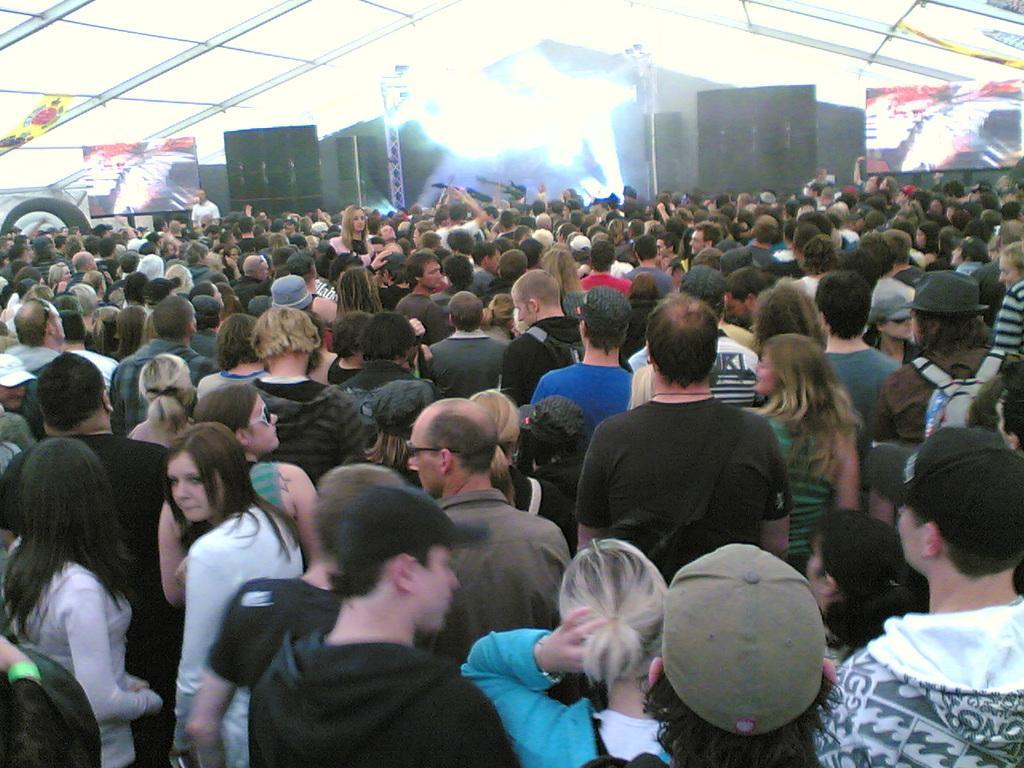Describe this image in one or two sentences. In this picture, we see many people are standing. In the background, we see men are holding the musical instruments in their hands. Behind them, we see speaker boxes and poles. On either side of the picture, we see screens. At the top, we see the roof. This picture might be clicked in the musical concert. 